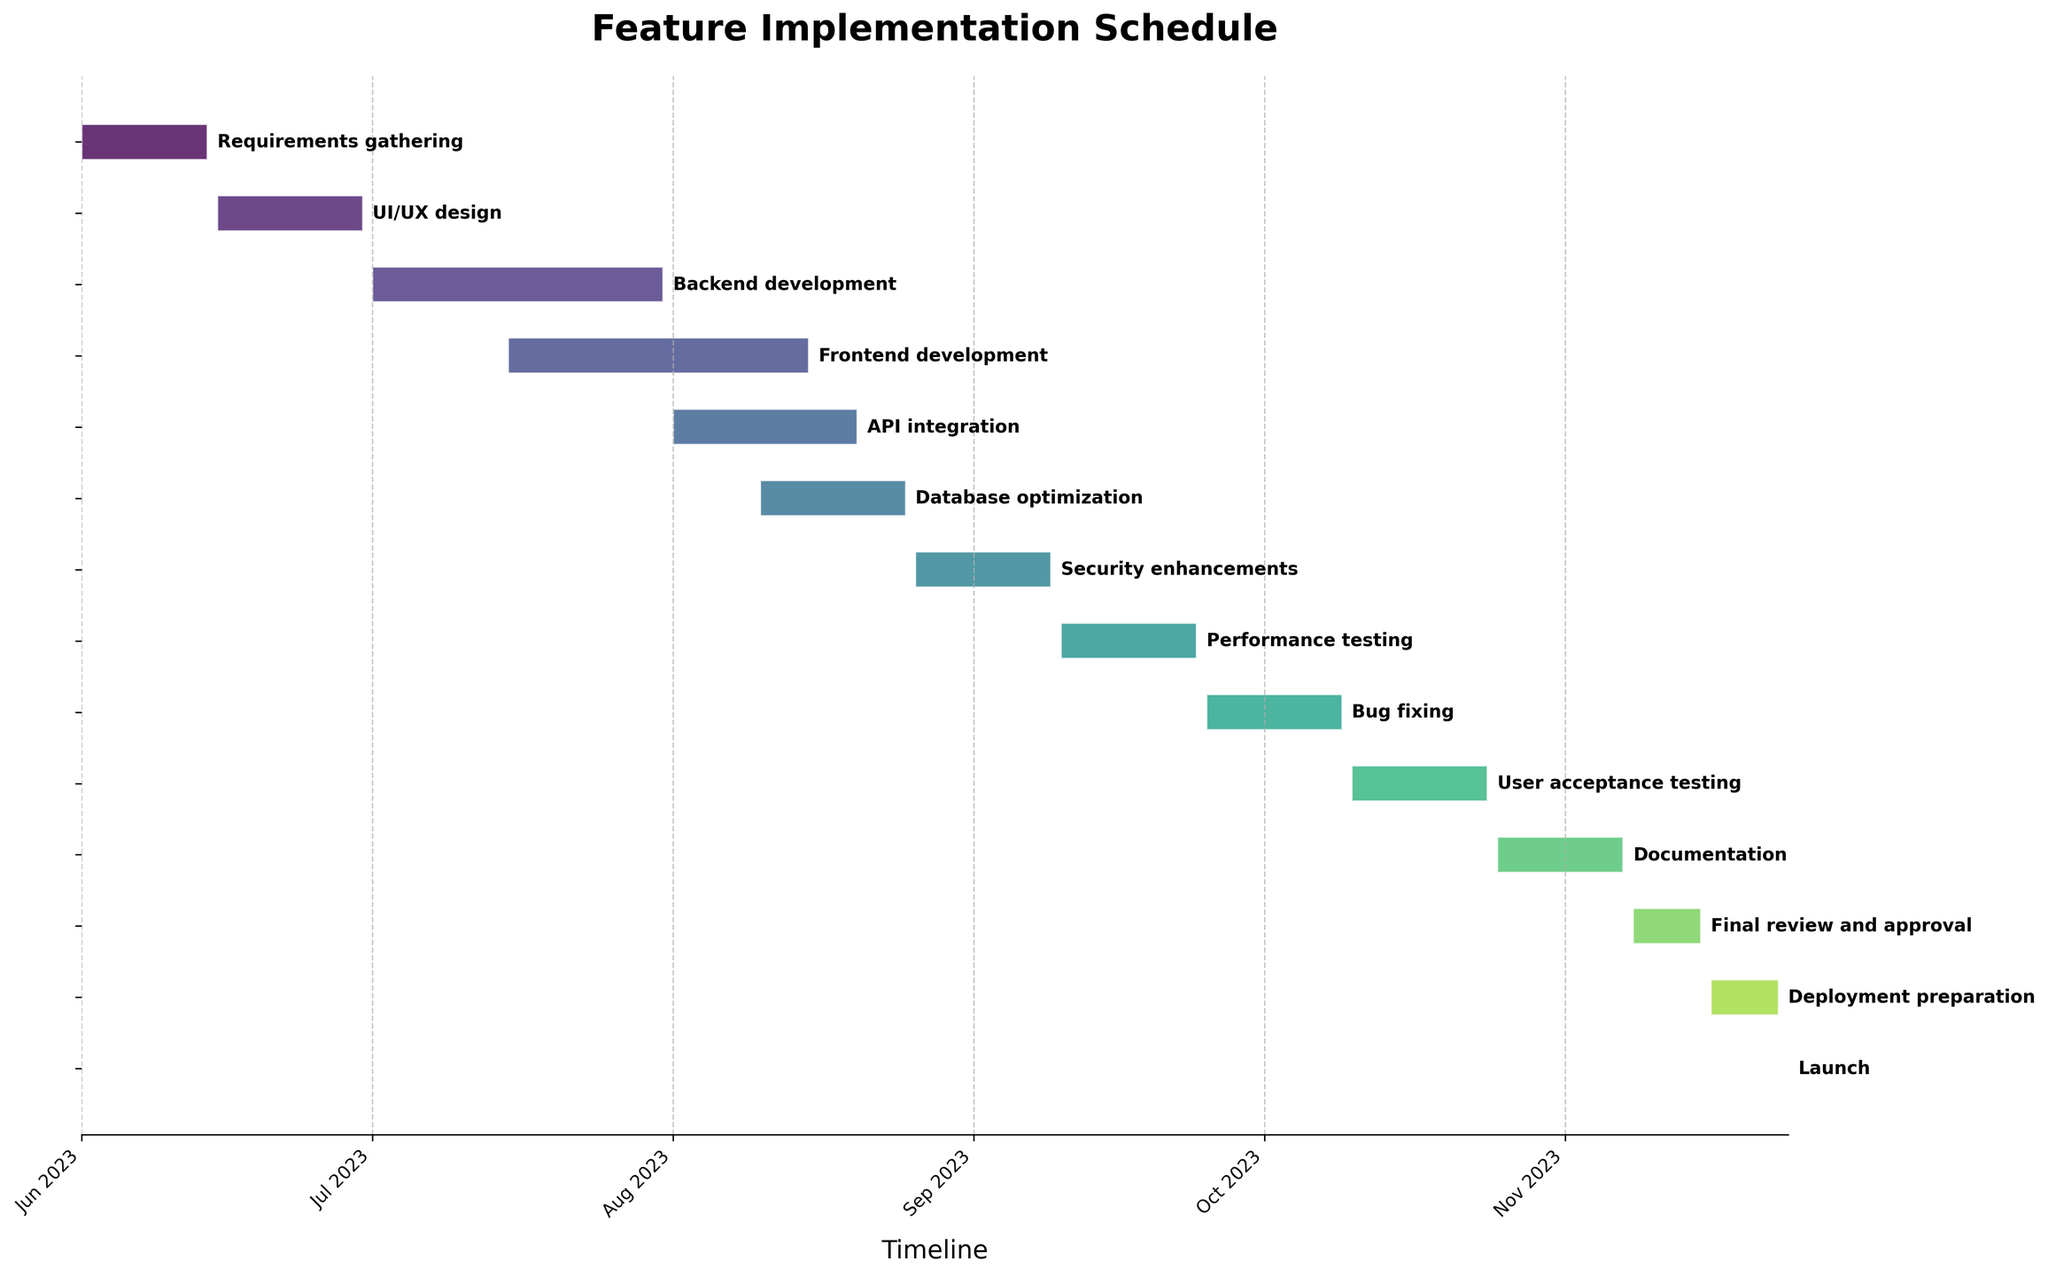What's the title of the chart? The title is displayed prominently at the top of the chart. It helps to quickly understand what the chart is about.
Answer: Feature Implementation Schedule Which task has the longest duration? By comparing the length of the horizontal bars, the task with the longest bar represents the longest duration. In this case, Backend development has the longest bar.
Answer: Backend development How many tasks are scheduled to start in July 2023? By looking at the start dates and mapping them to the x-axis, we can identify the tasks starting in July. Backend development and Frontend development start in July.
Answer: 2 Which task is immediately followed by 'API integration'? The task immediately after API integration on the y-axis provides the answer. Database optimization follows API integration.
Answer: Database optimization What is the duration of 'Bug fixing'? The duration can be found by looking at the length of the horizontal bar for Bug fixing, which is labeled directly on the bar chart.
Answer: 15 days Are there any tasks that overlap with 'Frontend development'? By examining the bars visually, any bars that intersect with Frontend development's duration (July 15 - August 15) are overlapping. API integration (August 1 - August 20) and Database optimization (August 10 - August 25) overlap with Frontend development.
Answer: Yes What's the total duration from 'Requirements gathering' to 'Launch'? Calculate by using the start date of Requirements gathering (June 1, 2023) to the launch date (November 24, 2023). That's approximately 177 days in total.
Answer: 177 days Which tasks have the same duration? Tasks with the same length of horizontal bars have the same duration. Security enhancements, Performance testing, Bug fixing, and User acceptance testing all have durations of 15 days.
Answer: Security enhancements, Performance testing, Bug fixing, User acceptance testing Does 'UI/UX design' start before or after 'Requirements gathering' ends? Comparing the end date of Requirements gathering (June 14, 2023) with the start date of UI/UX design (June 15, 2023) shows that UI/UX design starts the day after Requirements gathering ends.
Answer: After When does the last task before 'Launch' end? The bar for the task immediately before Launch is Deployment preparation, whose end date is November 23, 2023.
Answer: November 23, 2023 